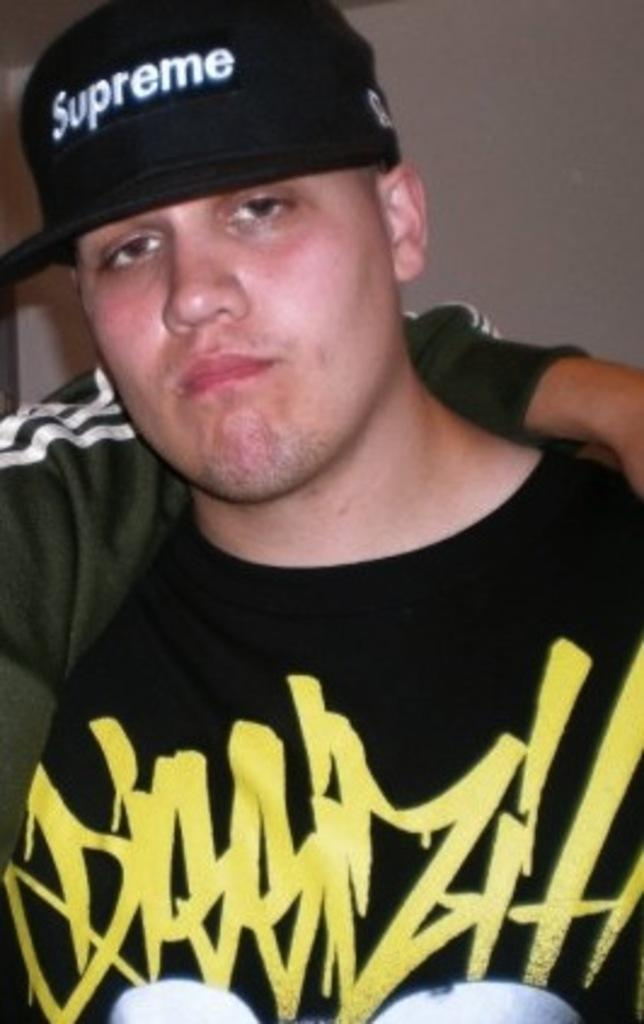<image>
Summarize the visual content of the image. the man is wearing a black Supreme hat 